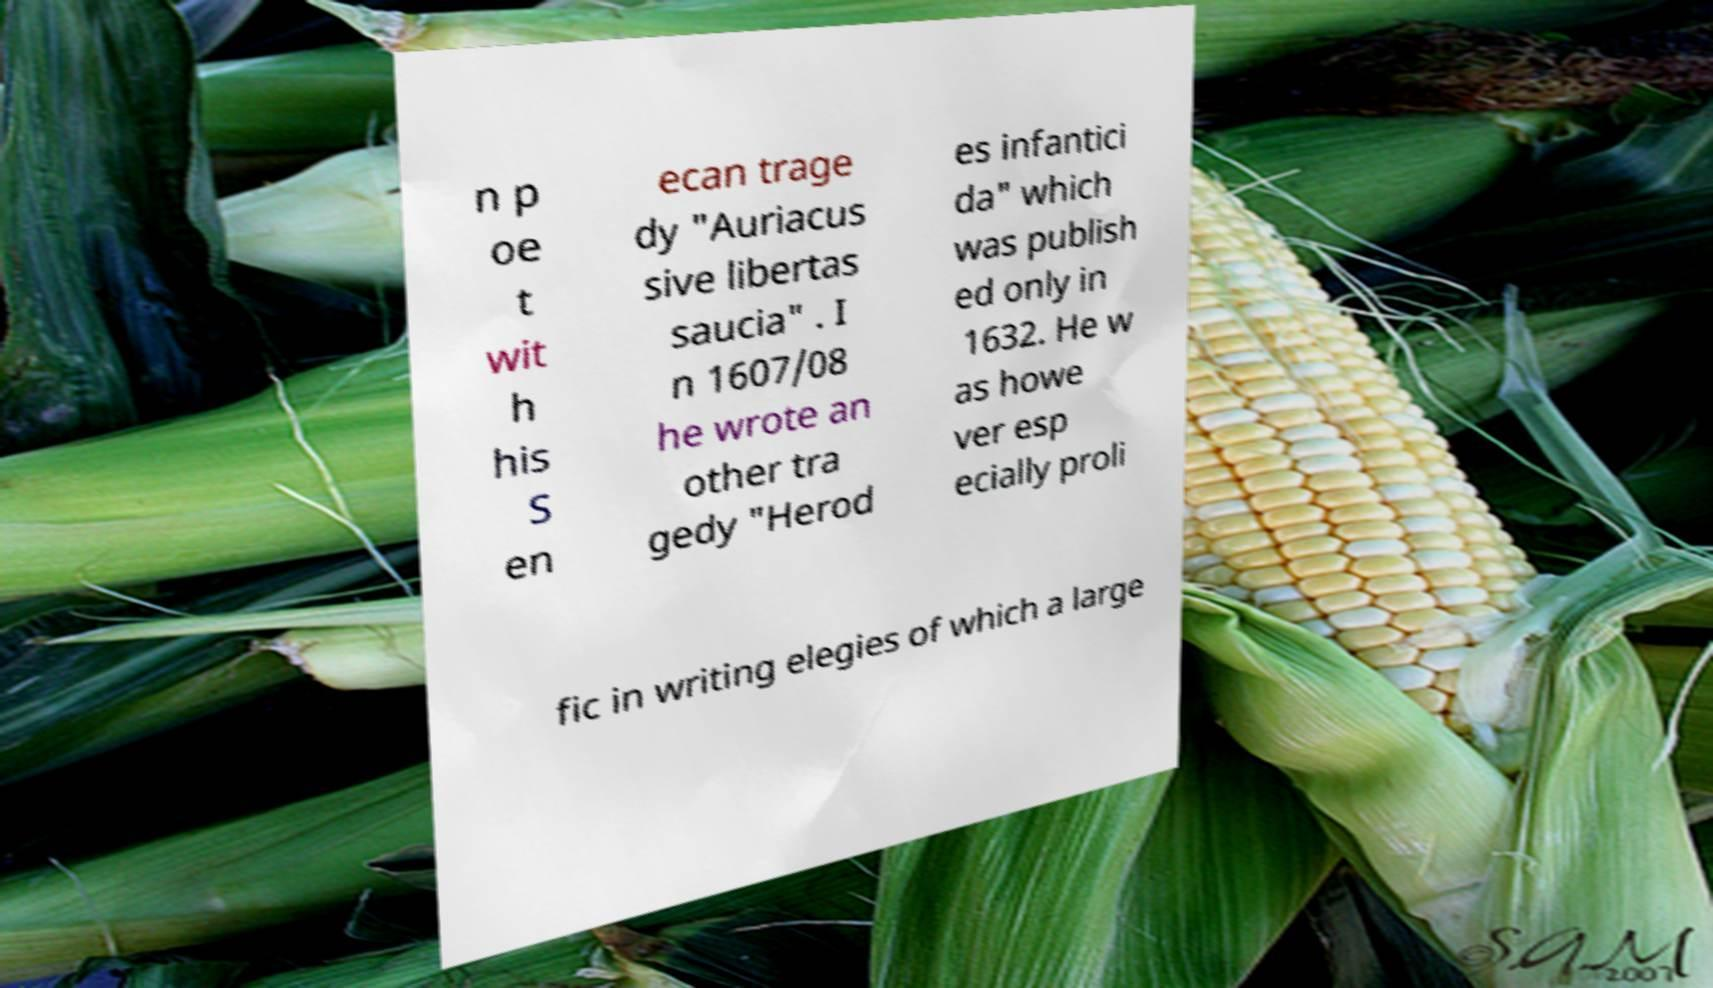Can you read and provide the text displayed in the image?This photo seems to have some interesting text. Can you extract and type it out for me? n p oe t wit h his S en ecan trage dy "Auriacus sive libertas saucia" . I n 1607/08 he wrote an other tra gedy "Herod es infantici da" which was publish ed only in 1632. He w as howe ver esp ecially proli fic in writing elegies of which a large 